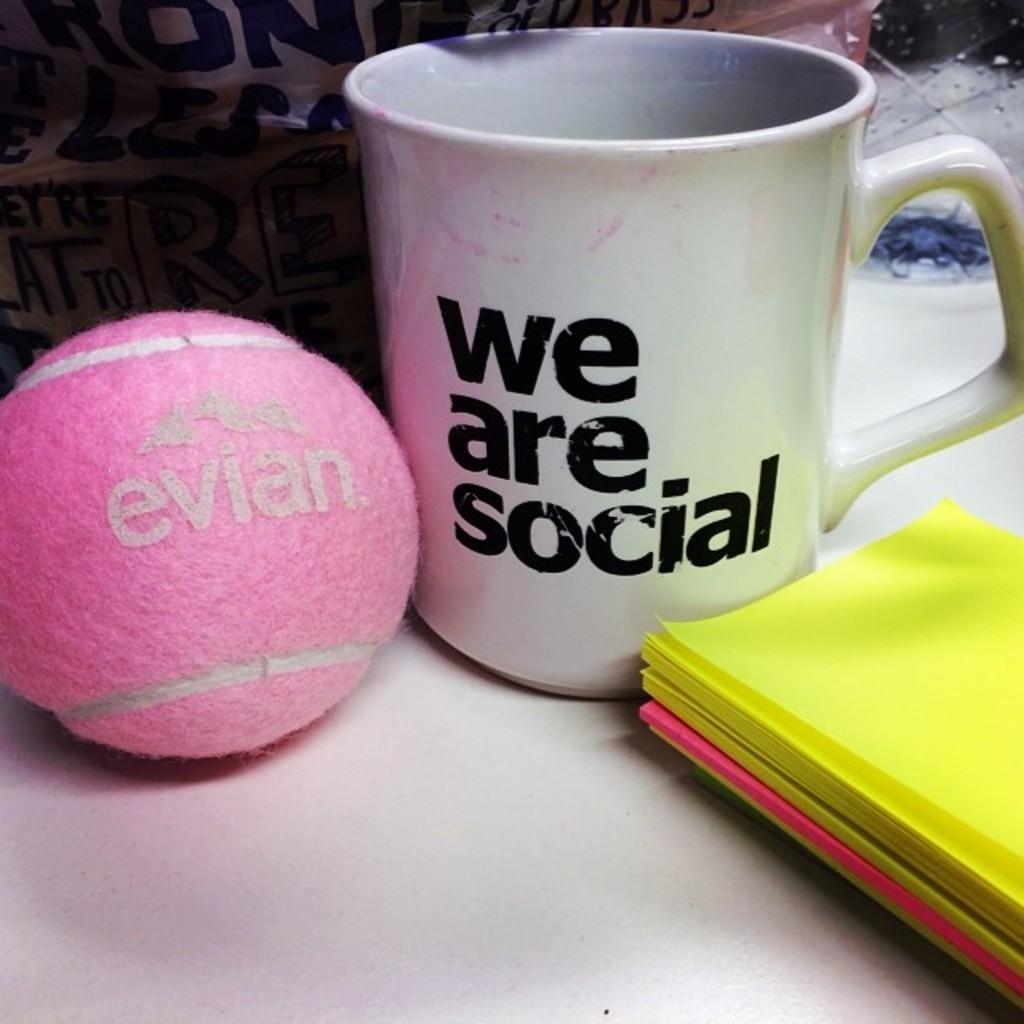Could you give a brief overview of what you see in this image? This image consists of a ball in pink color. On the right, there are papers in yellow color. In the middle, there is a coffee cup. At the bottom, there is a desk. 